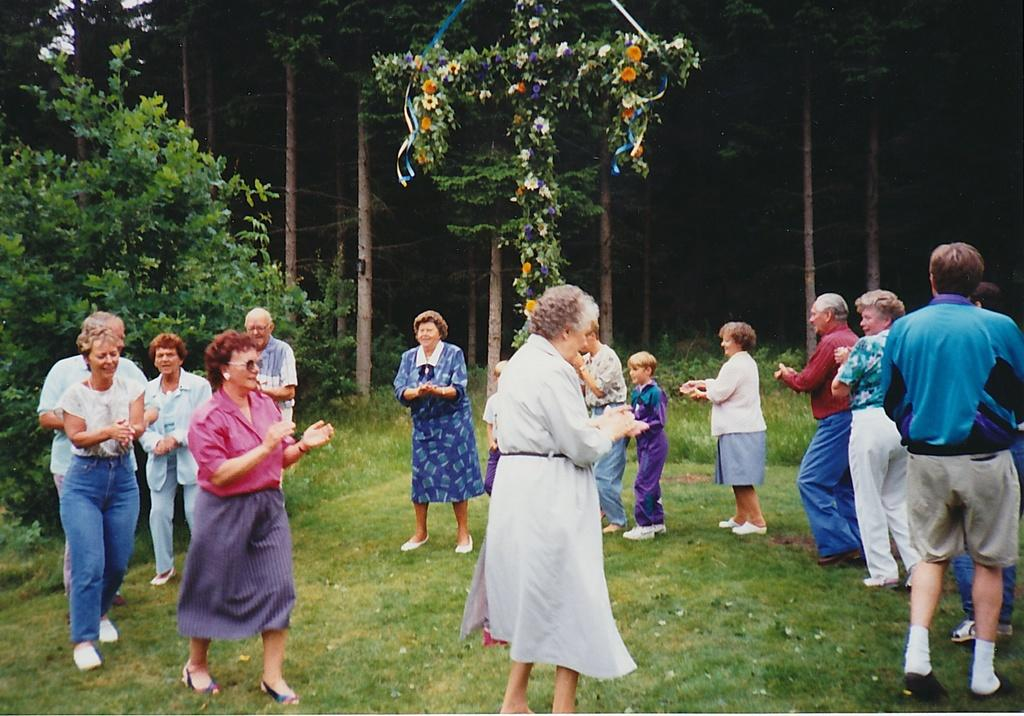How many people are in the group shown in the image? There is a group of persons in the image. What are the people in the group wearing? The persons are wearing dresses. Can you describe any specific accessory worn by one of the women? One woman is wearing goggles. Where are the people in the group standing? The group of persons is standing on the ground. What can be seen in the background of the image? There is a group of trees and flowers visible in the background of the image. How many eyes are visible on the goggles worn by the woman in the image? The goggles worn by the woman do not have eyes; they are a protective accessory for her eyes. 